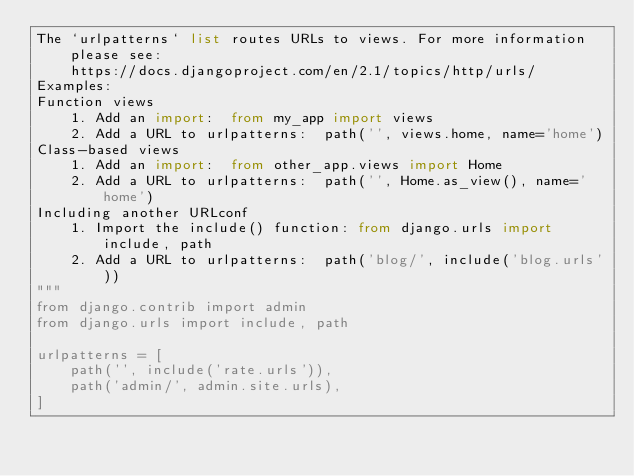Convert code to text. <code><loc_0><loc_0><loc_500><loc_500><_Python_>The `urlpatterns` list routes URLs to views. For more information please see:
    https://docs.djangoproject.com/en/2.1/topics/http/urls/
Examples:
Function views
    1. Add an import:  from my_app import views
    2. Add a URL to urlpatterns:  path('', views.home, name='home')
Class-based views
    1. Add an import:  from other_app.views import Home
    2. Add a URL to urlpatterns:  path('', Home.as_view(), name='home')
Including another URLconf
    1. Import the include() function: from django.urls import include, path
    2. Add a URL to urlpatterns:  path('blog/', include('blog.urls'))
"""
from django.contrib import admin
from django.urls import include, path

urlpatterns = [
    path('', include('rate.urls')),
    path('admin/', admin.site.urls),
]
</code> 